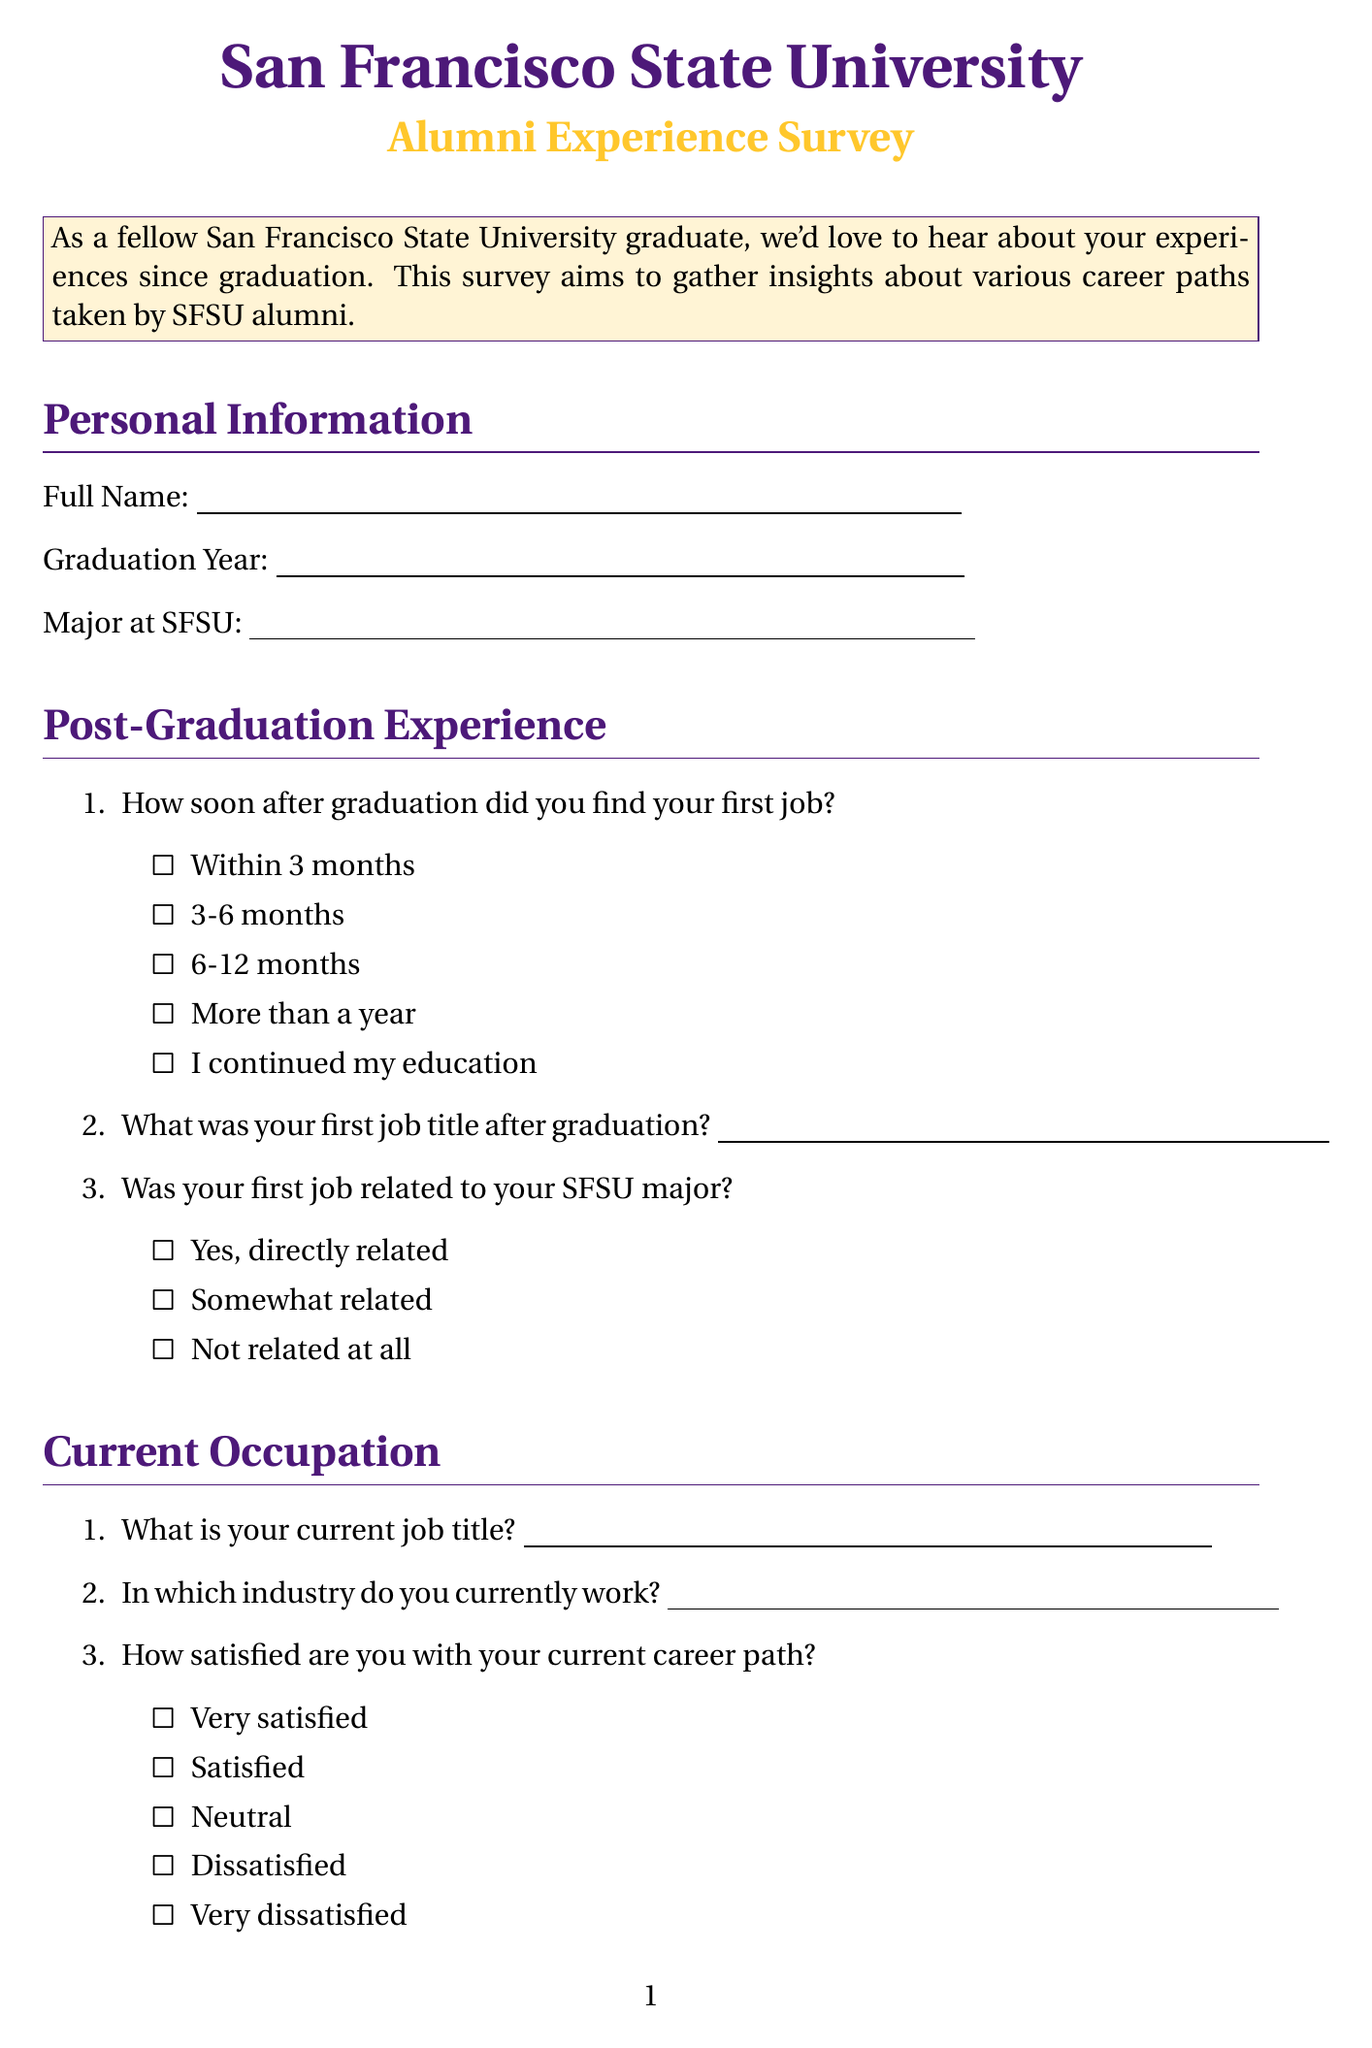What is the title of the document? The title is mentioned in the introduction at the beginning of the document.
Answer: San Francisco State University Alumni Experience Survey What year did Dean Grafilo graduate? The question asks for a graduation year, which can be found in the Personal Information section of the document.
Answer: Not specified What type of questions are included in the survey? The survey includes various question types that are listed in the sections throughout the document.
Answer: Text, multiple choice, long text What option indicates how soon after graduation one found a job? This option can be found in the Post-Graduation Experience section, which refers to employment timing after graduation.
Answer: Within 3 months What is requested in the "SFSU resources or programs" question? This question prompts for responses specifically about helpful resources related to career development, noted in the SFSU Impact section.
Answer: Open text response How often are alumni asked to participate in events? The frequency of participation is queried in the Alumni Engagement section of the survey.
Answer: Frequently, Occasionally, Rarely, Never What is one of the options for career path satisfaction? The satisfaction with the current career path is listed in the Current Occupation section, which includes multiple choice answers.
Answer: Very satisfied What does the "Career Path Comparison" section explore? This section compares individual career paths to those of SFSU classmates and includes specific questions related to familiarity with Dean Grafilo.
Answer: Comparison of career paths What would alumni be asked regarding mentoring current students? The document includes a question about alumni interest in mentoring, found in the Alumni Engagement section.
Answer: Yes, definitely, Maybe, No, not at this time 